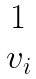Convert formula to latex. <formula><loc_0><loc_0><loc_500><loc_500>\begin{matrix} 1 \\ v _ { i } \end{matrix}</formula> 